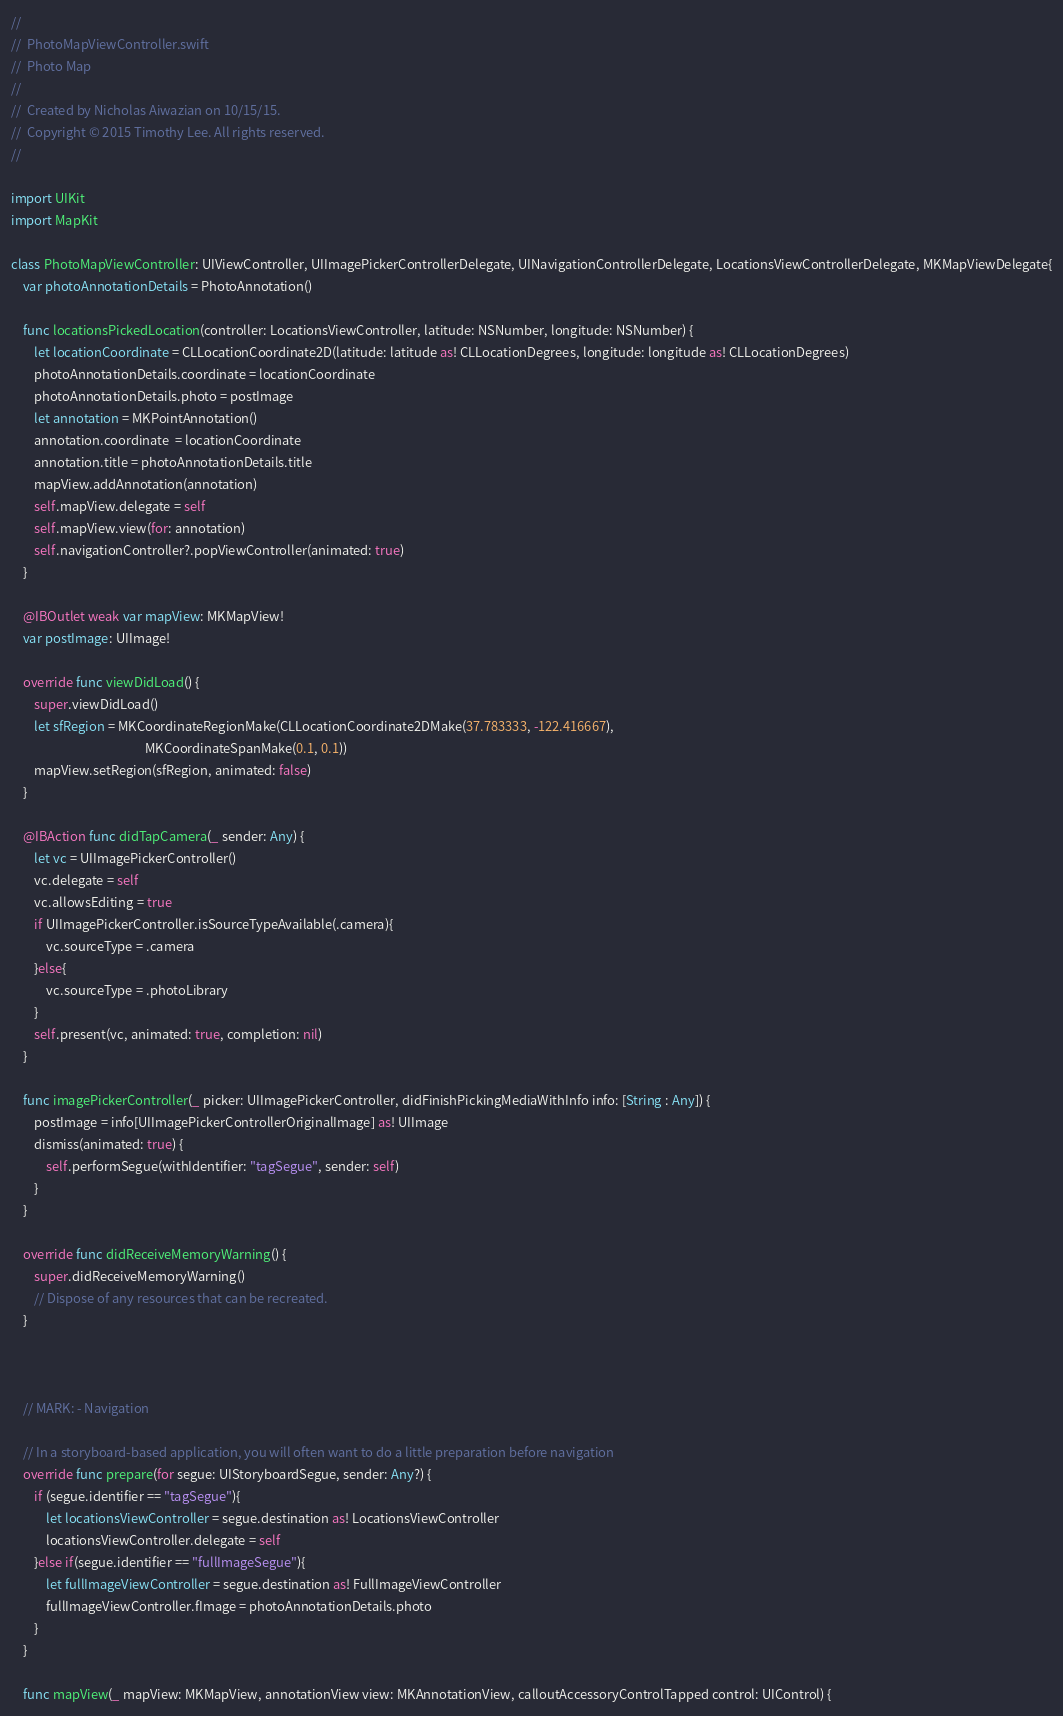Convert code to text. <code><loc_0><loc_0><loc_500><loc_500><_Swift_>//
//  PhotoMapViewController.swift
//  Photo Map
//
//  Created by Nicholas Aiwazian on 10/15/15.
//  Copyright © 2015 Timothy Lee. All rights reserved.
//

import UIKit
import MapKit

class PhotoMapViewController: UIViewController, UIImagePickerControllerDelegate, UINavigationControllerDelegate, LocationsViewControllerDelegate, MKMapViewDelegate{
    var photoAnnotationDetails = PhotoAnnotation()

    func locationsPickedLocation(controller: LocationsViewController, latitude: NSNumber, longitude: NSNumber) {
        let locationCoordinate = CLLocationCoordinate2D(latitude: latitude as! CLLocationDegrees, longitude: longitude as! CLLocationDegrees)
        photoAnnotationDetails.coordinate = locationCoordinate
        photoAnnotationDetails.photo = postImage
        let annotation = MKPointAnnotation()
        annotation.coordinate  = locationCoordinate
        annotation.title = photoAnnotationDetails.title
        mapView.addAnnotation(annotation)
        self.mapView.delegate = self
        self.mapView.view(for: annotation)
        self.navigationController?.popViewController(animated: true)
    }
    
    @IBOutlet weak var mapView: MKMapView!
    var postImage: UIImage!
    
    override func viewDidLoad() {
        super.viewDidLoad()
        let sfRegion = MKCoordinateRegionMake(CLLocationCoordinate2DMake(37.783333, -122.416667),
                                              MKCoordinateSpanMake(0.1, 0.1))
        mapView.setRegion(sfRegion, animated: false)
    }

    @IBAction func didTapCamera(_ sender: Any) {
        let vc = UIImagePickerController()
        vc.delegate = self
        vc.allowsEditing = true
        if UIImagePickerController.isSourceTypeAvailable(.camera){
            vc.sourceType = .camera
        }else{
            vc.sourceType = .photoLibrary
        }
        self.present(vc, animated: true, completion: nil)
    }
    
    func imagePickerController(_ picker: UIImagePickerController, didFinishPickingMediaWithInfo info: [String : Any]) {
        postImage = info[UIImagePickerControllerOriginalImage] as! UIImage
        dismiss(animated: true) {
            self.performSegue(withIdentifier: "tagSegue", sender: self)
        }
    }
    
    override func didReceiveMemoryWarning() {
        super.didReceiveMemoryWarning()
        // Dispose of any resources that can be recreated.
    }
    

    
    // MARK: - Navigation

    // In a storyboard-based application, you will often want to do a little preparation before navigation
    override func prepare(for segue: UIStoryboardSegue, sender: Any?) {
        if (segue.identifier == "tagSegue"){
            let locationsViewController = segue.destination as! LocationsViewController
            locationsViewController.delegate = self
        }else if(segue.identifier == "fullImageSegue"){
            let fullImageViewController = segue.destination as! FullImageViewController
            fullImageViewController.fImage = photoAnnotationDetails.photo
        }
    }
    
    func mapView(_ mapView: MKMapView, annotationView view: MKAnnotationView, calloutAccessoryControlTapped control: UIControl) {</code> 